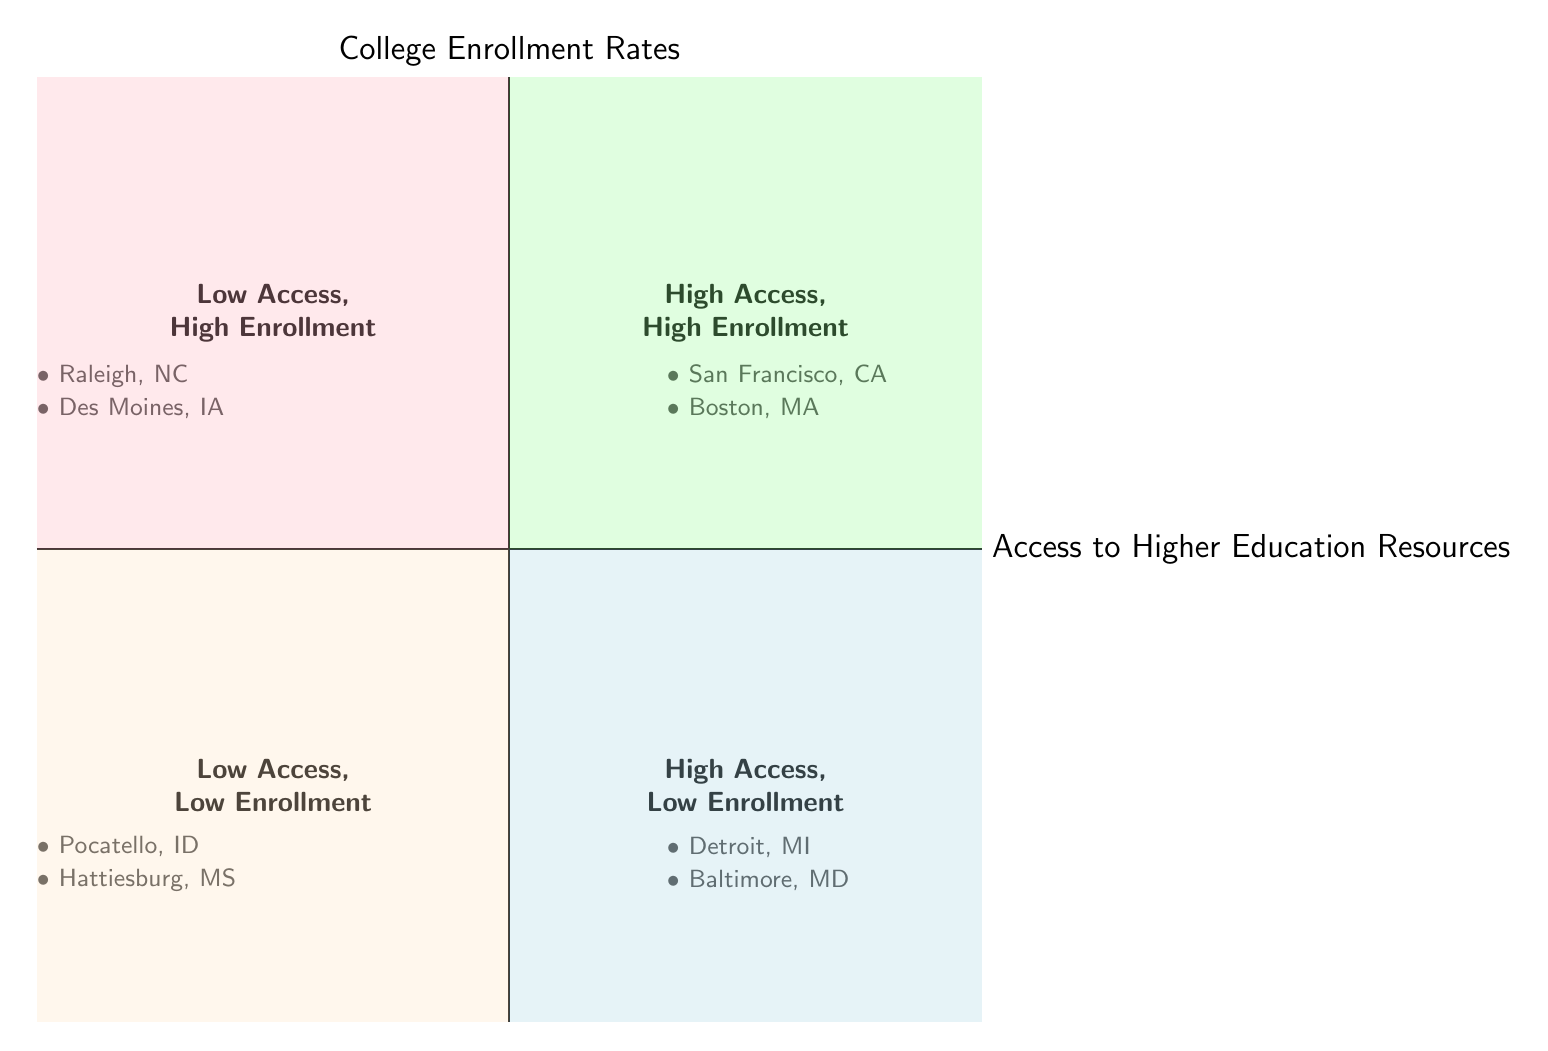What city has the highest enrollment rate in the High Access, High Enrollment quadrant? In the High Access, High Enrollment quadrant, San Francisco, CA has an enrollment rate of 70%, while Boston, MA has a higher rate of 75%. Therefore, the city with the highest enrollment rate is Boston, MA.
Answer: Boston, MA Which quadrant contains Pocatello, ID? Pocatello, ID is listed in the Low Access, Low Enrollment quadrant, as indicated in the diagram where this city is mentioned.
Answer: Low Access, Low Enrollment How many cities are in the High Access, Low Enrollment quadrant? The High Access, Low Enrollment quadrant displays two cities: Detroit, MI and Baltimore, MD. Thus, there are two cities in this quadrant.
Answer: 2 What is the enrollment rate for Raleigh, NC? Raleigh, NC is located in the Low Access, High Enrollment quadrant with an enrollment rate of 65%, as stated in the diagram.
Answer: 65% Which city has moderate academic counseling yet still shows a high enrollment rate? Des Moines, IA is associated with having a moderate number of academic counselors while maintaining a high enrollment rate of 60%. This indicates a contradiction in expectations on support vs. participation.
Answer: Des Moines, IA Are there any cities in the Low Access, Low Enrollment quadrant with enrollment rates above 40%? Both cities in the Low Access, Low Enrollment quadrant, Pocatello, ID with 30% and Hattiesburg, MS with 35%, are below 40%, confirming no cities in this category exceed that rate.
Answer: No Which quadrant features both high access and low enrollment cities? The High Access, Low Enrollment quadrant contains cities like Detroit, MI and Baltimore, MD, where access is high, but the enrollment rates are lower than expected.
Answer: High Access, Low Enrollment What common characteristic do cities in the Low Access, High Enrollment quadrant share? The cities in the Low Access, High Enrollment quadrant, like Raleigh, NC and Des Moines, IA, illustrate that they have limited access but still manage to achieve decent enrollment rates, indicating other factors may boost admission.
Answer: Limited access What could be inferred about the relationship between resource access and enrollment rates in urban areas compared to rural areas? The quadrant chart suggests that urban areas with high access resources contribute significantly to higher enrollment rates, while rural areas often struggle with lower access and, consequently, lower enrollment, indicating a correlation that functions differently in these environments.
Answer: Urban vs. rural correlation 